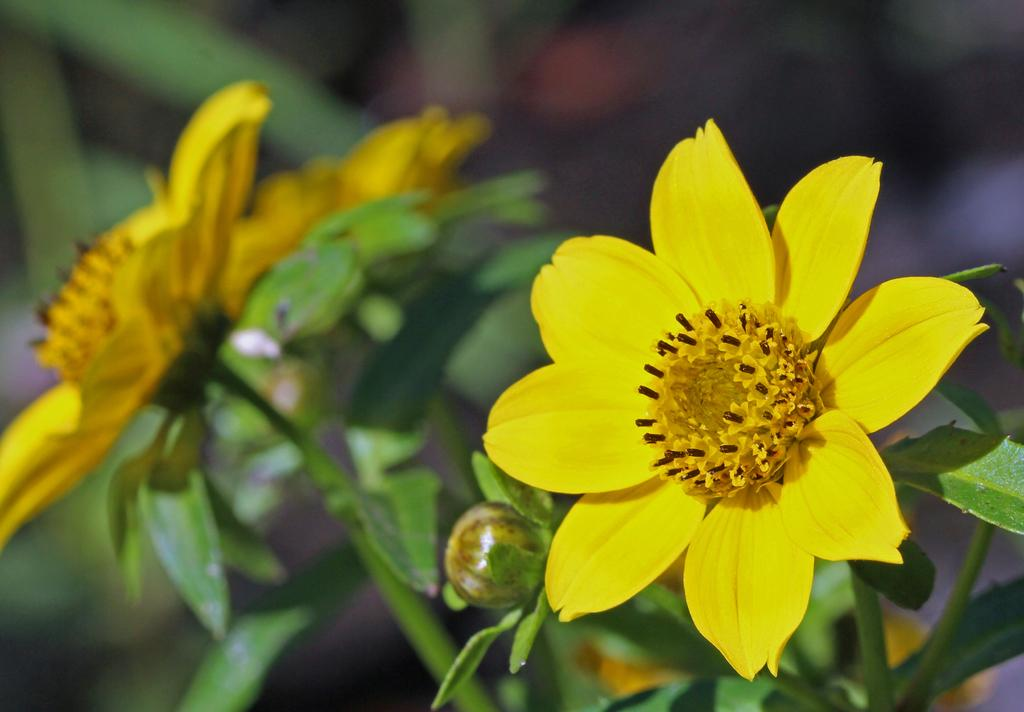What type of flowers can be seen in the image? There are yellow flowers in the image. What stage of growth are some of the flowers in? There are buds in the image, which indicates that some flowers are in the early stages of growth. What other plant parts can be seen in the image? There are leaves in the image. How would you describe the background of the image? The background of the image is blurred. What type of copper drum can be seen in the image? There is no copper drum present in the image. What is the engine used for in the image? There is no engine present in the image. 